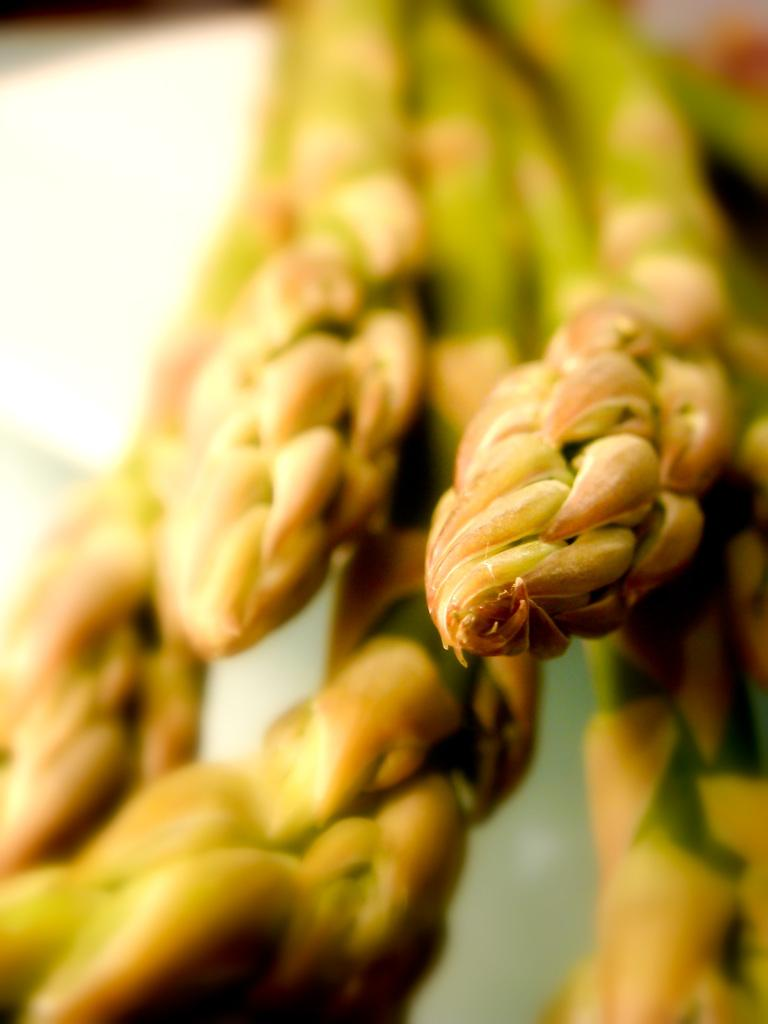What type of grains are visible in the image? There are wheat grains in the image. Can you describe the background of the image? The background of the image is blurred. Can you see your aunt standing on an island in the image? There is no reference to an aunt, an island, or a judge in the image, so it is not possible to answer that question. 